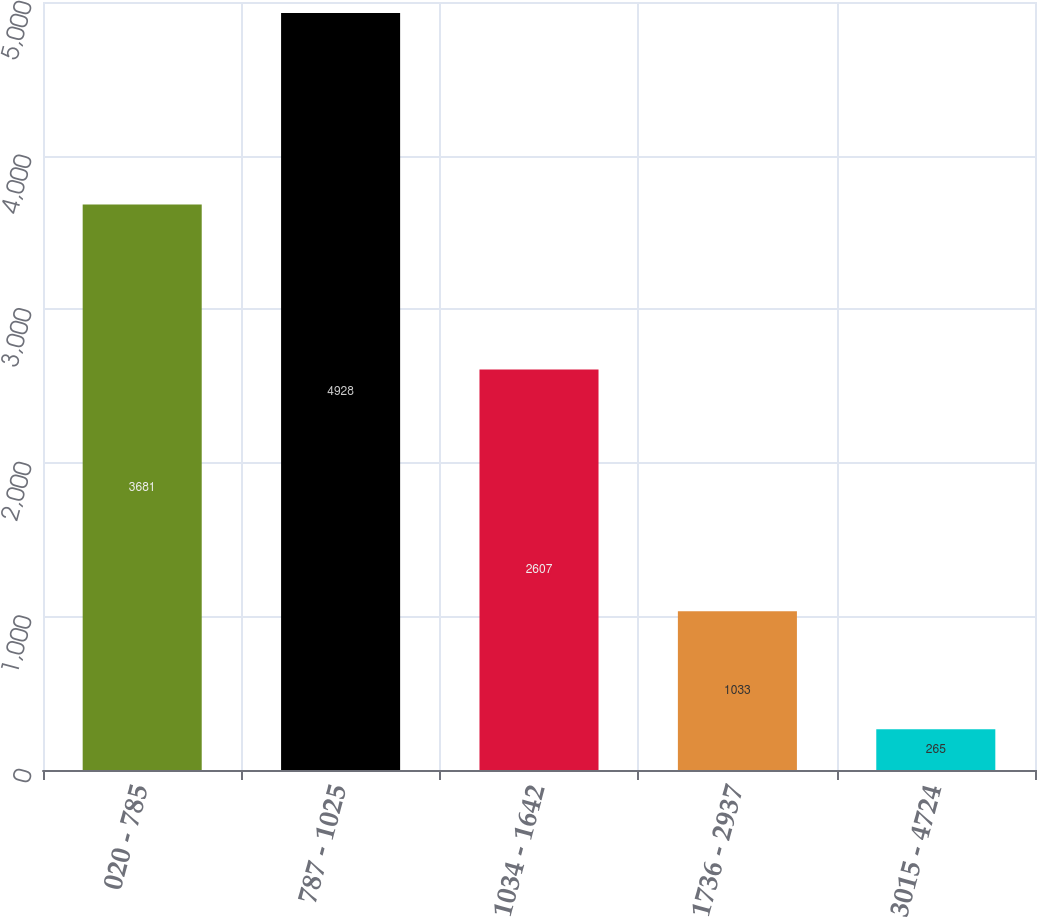<chart> <loc_0><loc_0><loc_500><loc_500><bar_chart><fcel>020 - 785<fcel>787 - 1025<fcel>1034 - 1642<fcel>1736 - 2937<fcel>3015 - 4724<nl><fcel>3681<fcel>4928<fcel>2607<fcel>1033<fcel>265<nl></chart> 